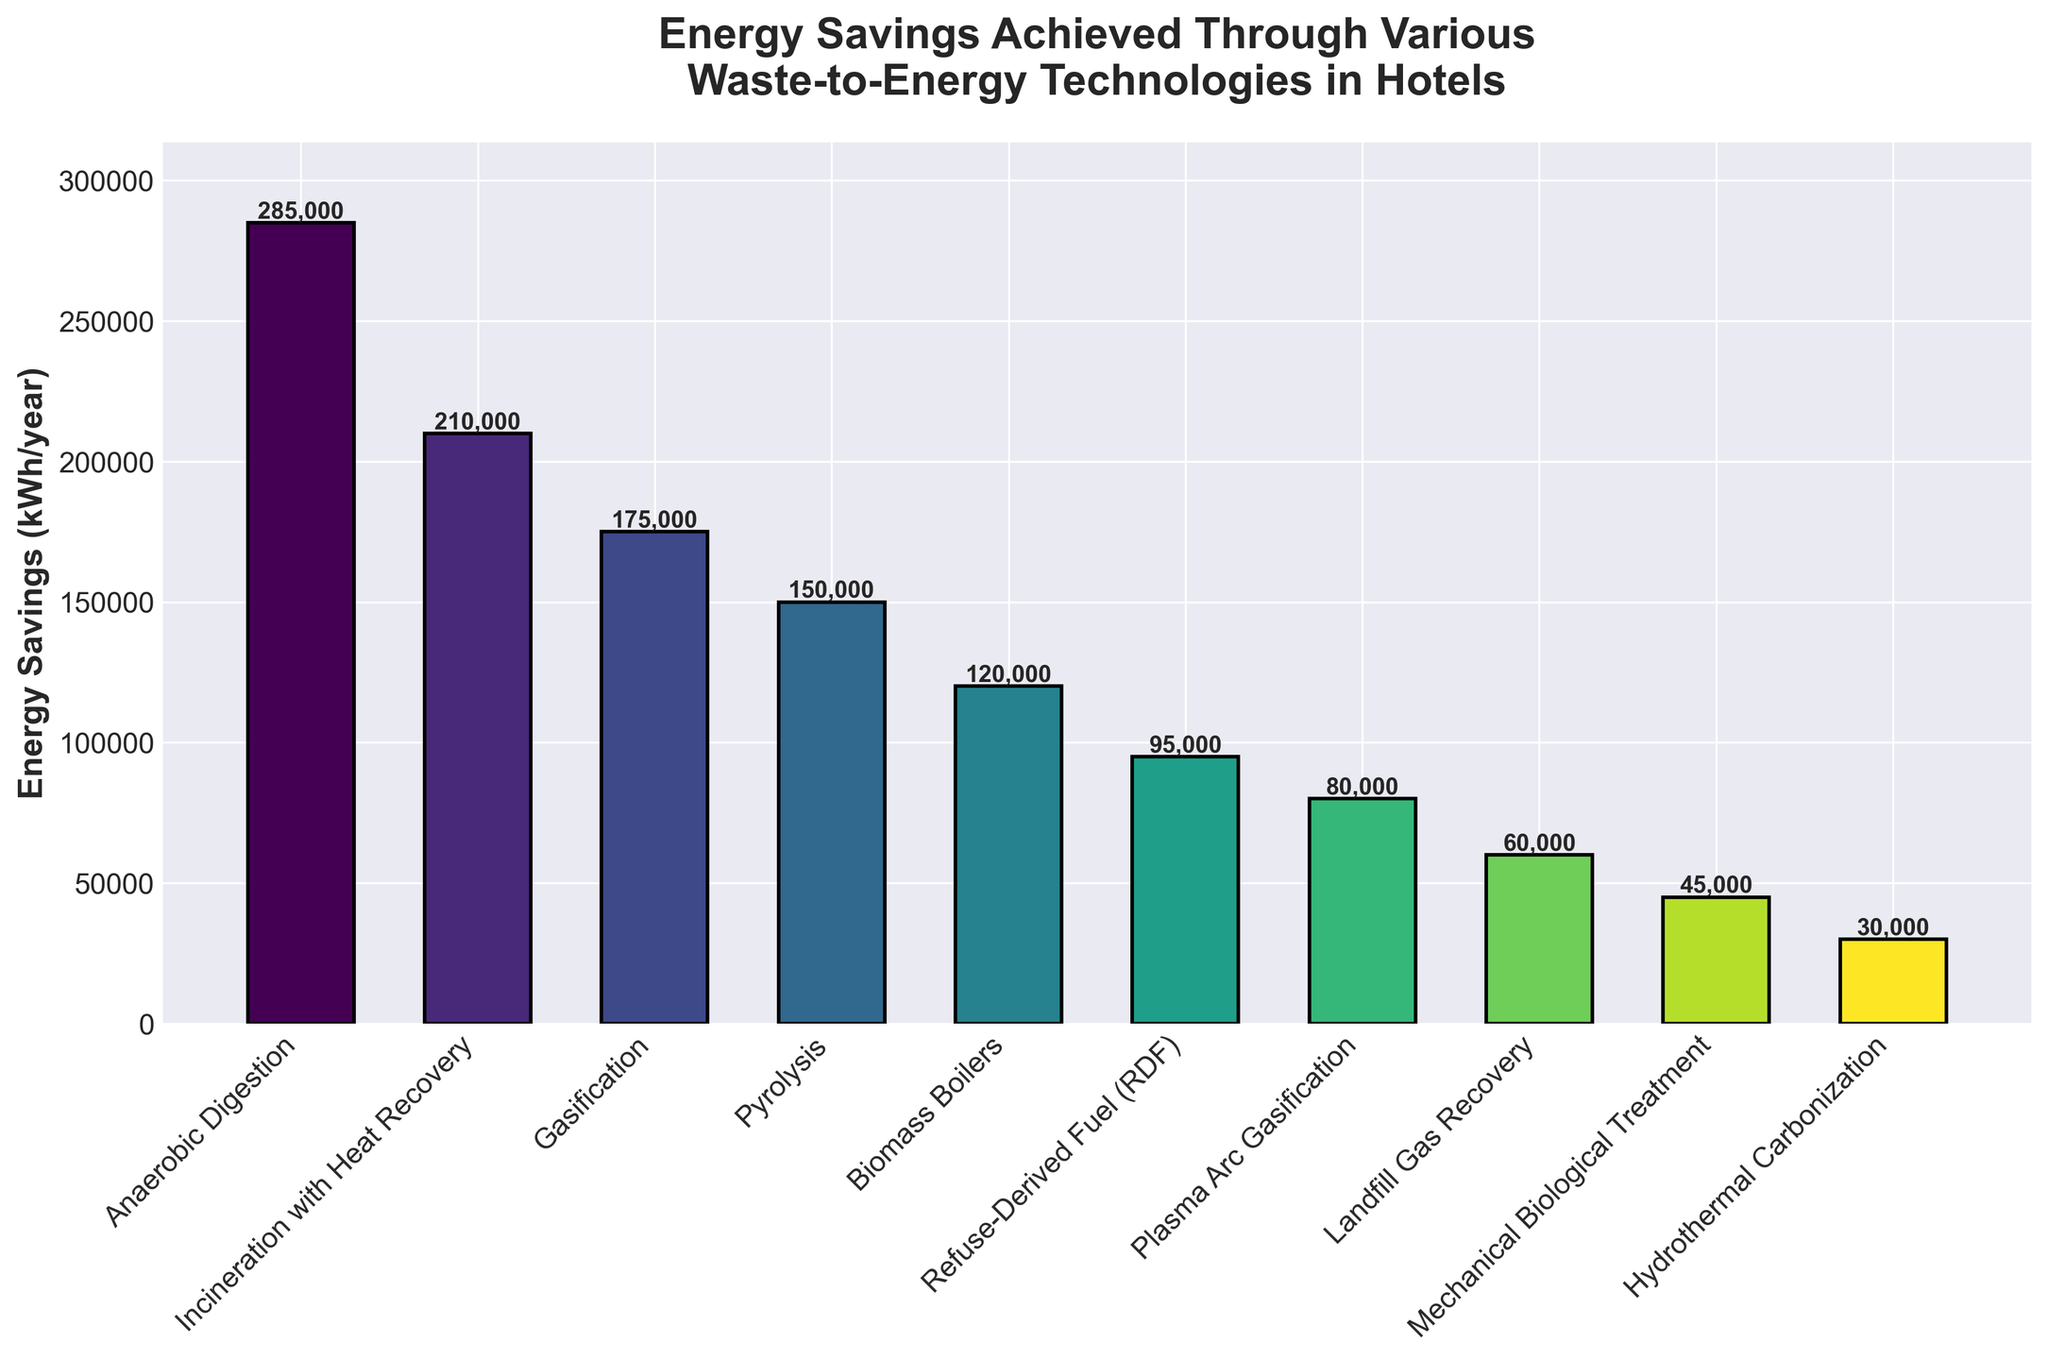What's the technology with the highest energy savings? By looking at the bar heights, the tallest bar represents the technology with the highest energy savings.
Answer: Anaerobic Digestion Which two technologies have the smallest energy savings? The shortest two bars indicate the technologies with the smallest energy savings.
Answer: Hydrothermal Carbonization, Mechanical Biological Treatment How much greater are the energy savings of Anaerobic Digestion compared to Gasification? Subtract the energy savings of Gasification from those of Anaerobic Digestion (285,000 - 175,000).
Answer: 110,000 kWh/year What is the total energy savings for Biomass Boilers, Pyrolysis, and Gasification combined? Sum the energy savings of Biomass Boilers (120,000), Pyrolysis (150,000), and Gasification (175,000). (120,000 + 150,000 + 175,000)
Answer: 445,000 kWh/year Rank the technologies producing energy savings from highest to lowest. Order the technologies based on the descending heights of their bars.
Answer: Anaerobic Digestion, Incineration with Heat Recovery, Gasification, Pyrolysis, Biomass Boilers, Refuse-Derived Fuel (RDF), Plasma Arc Gasification, Landfill Gas Recovery, Mechanical Biological Treatment, Hydrothermal Carbonization What is the difference in energy savings between the second and the fourth highest technologies? Identify the second (Incineration with Heat Recovery) and the fourth (Pyrolysis) highest technologies, then subtract their energy savings (210,000 - 150,000).
Answer: 60,000 kWh/year Which technology's bar has a height approximately half that of Incineration with Heat Recovery? Incineration with Heat Recovery has energy savings of 210,000. The bar with savings close to half of 210,000 (i.e., 105,000) is Refuse-Derived Fuel (RDF) with 95,000.
Answer: Refuse-Derived Fuel (RDF) Do any technologies provide the same amount of energy savings? By comparing all the bars, no two bars have the same height, indicating different energy savings for each technology.
Answer: No What is the average energy savings of all technologies combined? Sum all the energy savings values and divide by the number of technologies. (285,000 + 210,000 + 175,000 + 150,000 + 120,000 + 95,000 + 80,000 + 60,000 + 45,000 + 30,000) / 10
Answer: 125,000 kWh/year What percentage of total energy savings is attributed to Anaerobic Digestion? Calculate the total energy savings for all technologies first (sum from above question), then find the percentage for Anaerobic Digestion. (285,000 / 1,250,000) * 100
Answer: 22.8% 